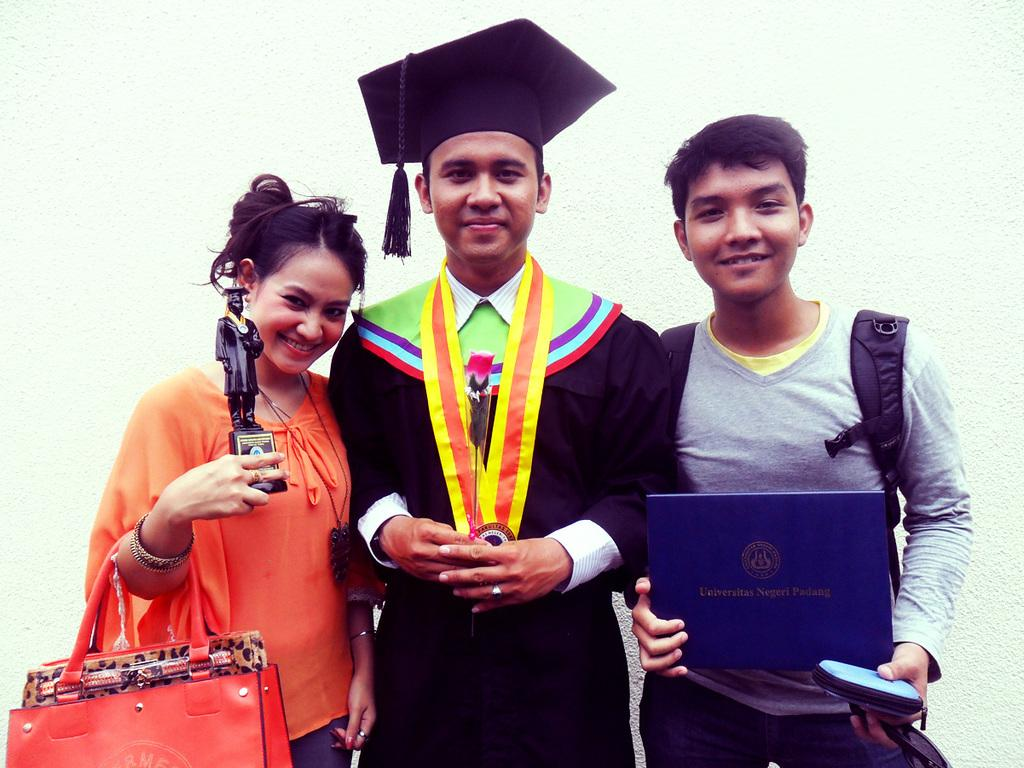How many people are in the image? There are three persons standing in the image. What are the people in the image doing? The persons are laughing. Can you describe the woman on the left side of the image? The woman on the left side of the image is holding a handbag. What can be seen in the background of the image? There is a wall visible in the background of the image. What type of wrench is being used to fix the part in the image? There is no wrench or part present in the image; it features three people laughing. How does the earthquake affect the persons in the image? There is no earthquake depicted in the image; the people are simply laughing. 